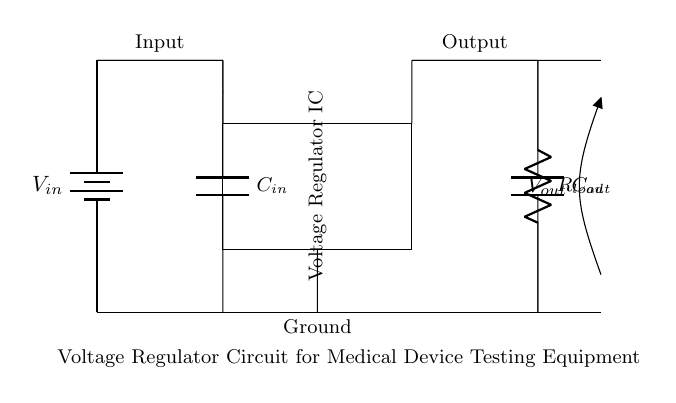What is the input voltage in the circuit? The input voltage is represented by the variable \( V_{in} \) near the battery symbol. This symbol indicates the source providing the voltage to the circuit.
Answer: V_{in} What type of capacitors are used in this circuit? The circuit diagram includes two capacitors labeled as \( C_{in} \) and \( C_{out} \). The 'C' designation indicates they are capacitors.
Answer: Capacitors What is the function of the voltage regulator IC? The voltage regulator IC is responsible for regulating the output voltage to a stable level, despite variations in input voltage or load conditions. This function is shown by the rectangle labeled "Voltage Regulator IC" in the diagram.
Answer: Regulation What are the load resistor dimensions in the circuit? The load resistor is labeled as \( R_{load} \), but no specific dimensions or values are provided in the diagram itself. Therefore, the information is not available.
Answer: Not specified How is the output voltage indicated in the circuit? The output voltage is indicated by the notation \( V_{out} \) at the open terminal in the output line. This signifies where the output voltage is measured in relation to the circuit.
Answer: V_{out} What can be inferred about the grounding in the circuit? The circuit has a ground connection indicated at the bottom, where several components connect to the same node, ensuring a common reference point for the voltage levels in the circuit.
Answer: Common ground Why is the input capacitor important in this circuit? The input capacitor \( C_{in} \) is important for filtering and stabilizing the input voltage, smoothing out any fluctuations, and providing a stable voltage to the voltage regulator's input. This function supports effective operation under varying load conditions.
Answer: Stability 